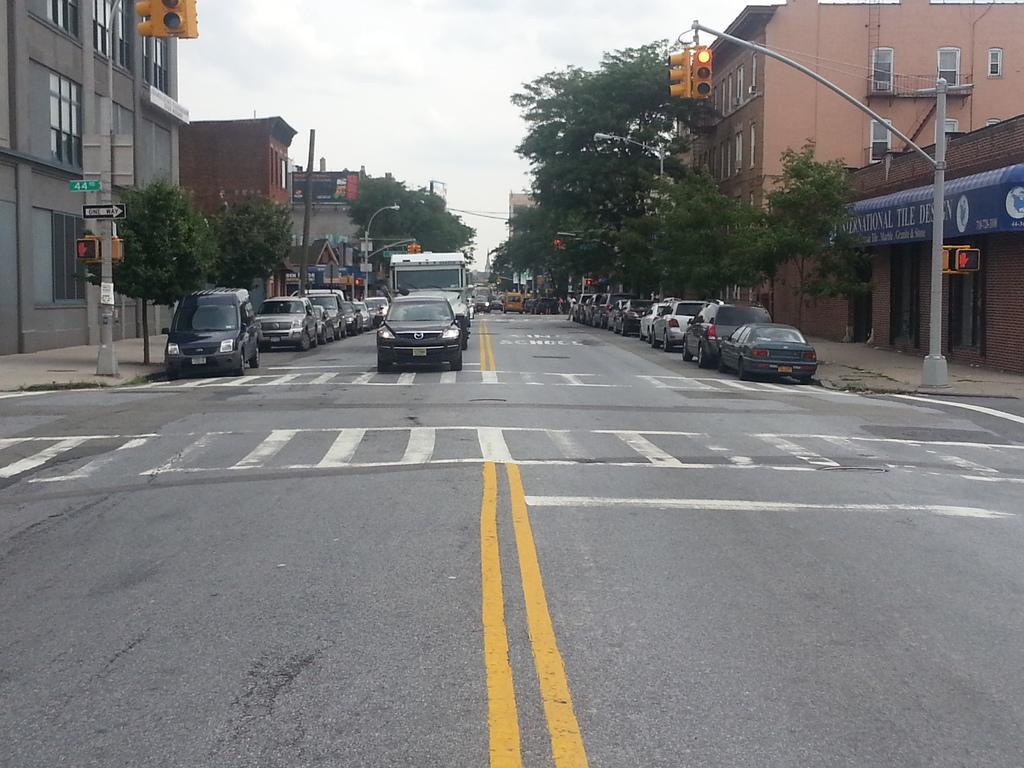How would you summarize this image in a sentence or two? In the center of the image we can see vehicles on the road. On the right side of the image we can see trees, poles, traffic signals and buildings. On the left side of the image we can see trees, buildings and traffic signals. In the background we can see sky and clouds. 